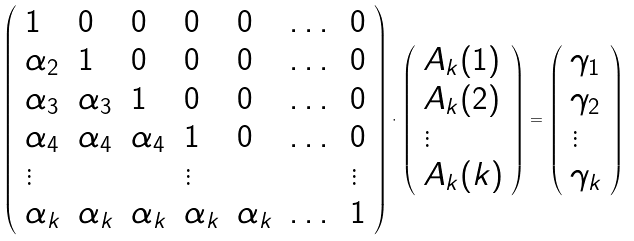Convert formula to latex. <formula><loc_0><loc_0><loc_500><loc_500>\left ( \begin{array} { l l l l l l l } 1 & 0 & 0 & 0 & 0 & \dots & 0 \\ \alpha _ { 2 } & 1 & 0 & 0 & 0 & \dots & 0 \\ \alpha _ { 3 } & \alpha _ { 3 } & 1 & 0 & 0 & \dots & 0 \\ \alpha _ { 4 } & \alpha _ { 4 } & \alpha _ { 4 } & 1 & 0 & \dots & 0 \\ \vdots & & & \vdots & & & \vdots \\ \alpha _ { k } & \alpha _ { k } & \alpha _ { k } & \alpha _ { k } & \alpha _ { k } & \dots & 1 \end{array} \right ) \cdot \left ( \begin{array} { l } A _ { k } ( 1 ) \\ A _ { k } ( 2 ) \\ \vdots \\ A _ { k } ( k ) \end{array} \right ) = \left ( \begin{array} { l } \gamma _ { 1 } \\ \gamma _ { 2 } \\ \vdots \\ \gamma _ { k } \end{array} \right )</formula> 